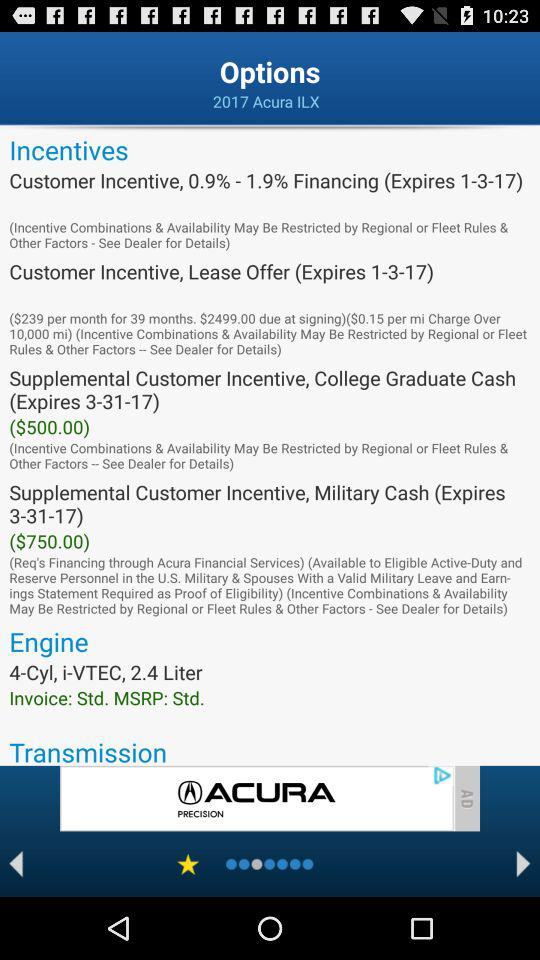When will the customer incentive lease offer expire? The offer will expire on January 3, 2017. 